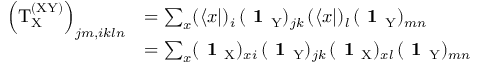<formula> <loc_0><loc_0><loc_500><loc_500>\begin{array} { r l } { \left ( T _ { \mathrm X } ^ { ( X Y ) } \right ) _ { j m , i k \ln } } & { = \sum _ { x } ( \langle x | ) _ { i } \, ( 1 _ { Y } ) _ { j k } \, ( \langle x | ) _ { l } \, ( 1 _ { Y } ) _ { m n } } \\ & { = \sum _ { x } ( 1 _ { X } ) _ { x i } \, ( 1 _ { Y } ) _ { j k } \, ( 1 _ { X } ) _ { x l } \, ( 1 _ { Y } ) _ { m n } } \end{array}</formula> 